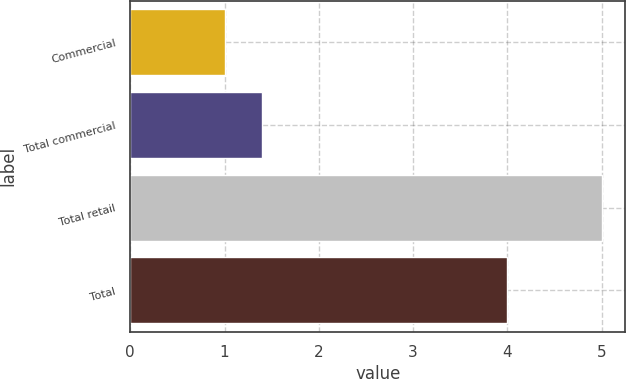Convert chart. <chart><loc_0><loc_0><loc_500><loc_500><bar_chart><fcel>Commercial<fcel>Total commercial<fcel>Total retail<fcel>Total<nl><fcel>1<fcel>1.4<fcel>5<fcel>4<nl></chart> 